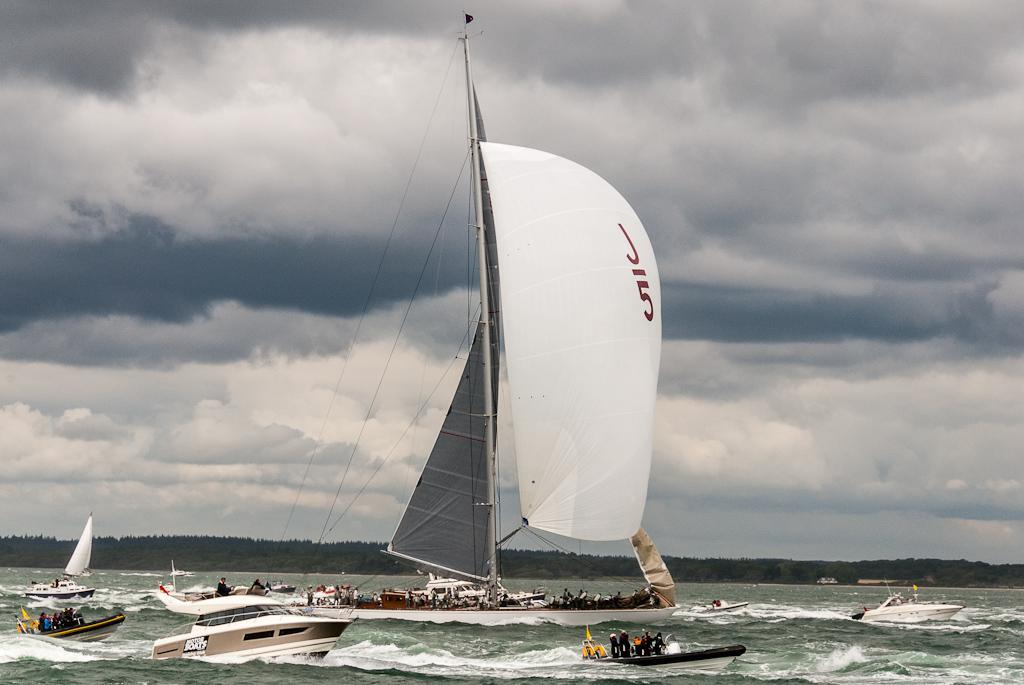What is happening in the water in the image? There are boats moving on the water in the image. What can be seen in the background of the image? There are trees visible in the background of the image. What is visible in the sky in the image? Clouds are present in the sky in the image. What type of war is being fought in the image? There is no war present in the image; it features boats moving on the water, trees in the background, and clouds in the sky. What story is being told in the image? The image does not depict a story; it is a visual representation of boats on the water, trees in the background, and clouds in the sky. 